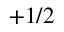Convert formula to latex. <formula><loc_0><loc_0><loc_500><loc_500>+ 1 / 2</formula> 